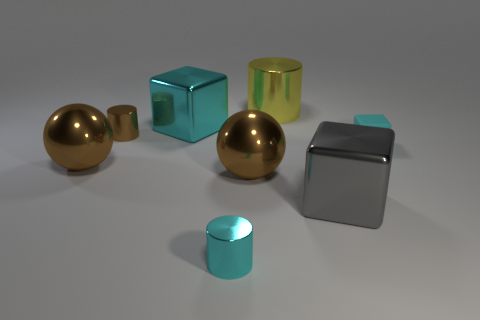Subtract all tiny shiny cylinders. How many cylinders are left? 1 Add 2 brown metallic spheres. How many objects exist? 10 Subtract 0 green cylinders. How many objects are left? 8 Subtract all blocks. How many objects are left? 5 Subtract all tiny green balls. Subtract all brown cylinders. How many objects are left? 7 Add 4 spheres. How many spheres are left? 6 Add 1 gray metal balls. How many gray metal balls exist? 1 